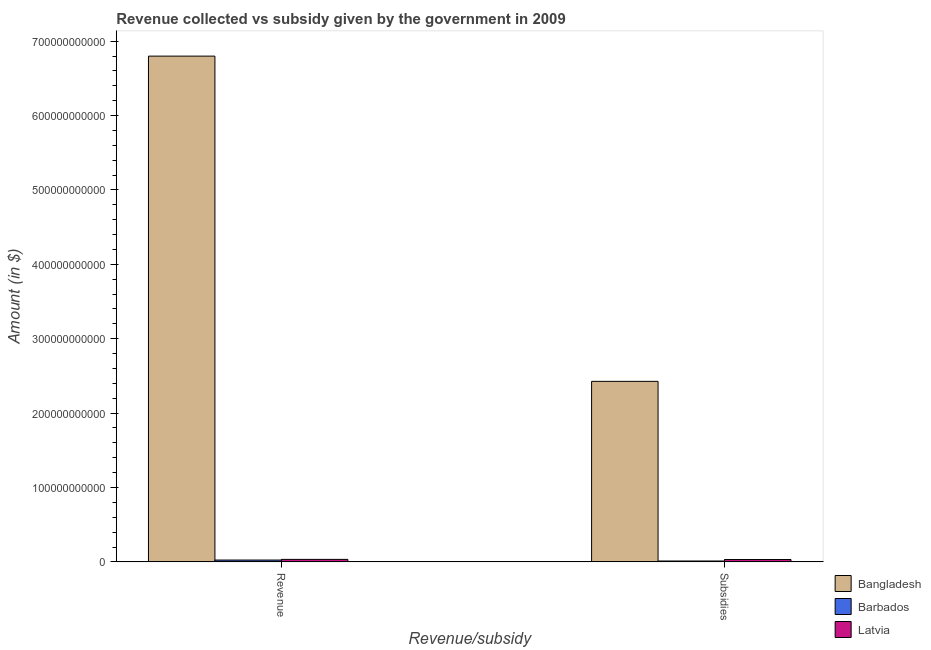How many different coloured bars are there?
Keep it short and to the point. 3. How many bars are there on the 2nd tick from the left?
Keep it short and to the point. 3. What is the label of the 2nd group of bars from the left?
Offer a terse response. Subsidies. What is the amount of revenue collected in Latvia?
Make the answer very short. 3.39e+09. Across all countries, what is the maximum amount of subsidies given?
Your answer should be very brief. 2.43e+11. Across all countries, what is the minimum amount of revenue collected?
Offer a very short reply. 2.50e+09. In which country was the amount of subsidies given minimum?
Your answer should be very brief. Barbados. What is the total amount of revenue collected in the graph?
Provide a short and direct response. 6.86e+11. What is the difference between the amount of revenue collected in Barbados and that in Bangladesh?
Provide a short and direct response. -6.77e+11. What is the difference between the amount of revenue collected in Latvia and the amount of subsidies given in Barbados?
Make the answer very short. 2.16e+09. What is the average amount of revenue collected per country?
Make the answer very short. 2.29e+11. What is the difference between the amount of revenue collected and amount of subsidies given in Bangladesh?
Provide a succinct answer. 4.37e+11. In how many countries, is the amount of revenue collected greater than 640000000000 $?
Your response must be concise. 1. What is the ratio of the amount of revenue collected in Latvia to that in Bangladesh?
Ensure brevity in your answer.  0. What does the 3rd bar from the left in Subsidies represents?
Give a very brief answer. Latvia. What does the 3rd bar from the right in Subsidies represents?
Keep it short and to the point. Bangladesh. How many bars are there?
Offer a very short reply. 6. How many countries are there in the graph?
Provide a succinct answer. 3. What is the difference between two consecutive major ticks on the Y-axis?
Give a very brief answer. 1.00e+11. Does the graph contain any zero values?
Provide a succinct answer. No. Does the graph contain grids?
Give a very brief answer. No. Where does the legend appear in the graph?
Offer a terse response. Bottom right. How many legend labels are there?
Provide a short and direct response. 3. How are the legend labels stacked?
Offer a very short reply. Vertical. What is the title of the graph?
Provide a succinct answer. Revenue collected vs subsidy given by the government in 2009. Does "High income" appear as one of the legend labels in the graph?
Your answer should be very brief. No. What is the label or title of the X-axis?
Offer a terse response. Revenue/subsidy. What is the label or title of the Y-axis?
Provide a short and direct response. Amount (in $). What is the Amount (in $) of Bangladesh in Revenue?
Make the answer very short. 6.80e+11. What is the Amount (in $) in Barbados in Revenue?
Ensure brevity in your answer.  2.50e+09. What is the Amount (in $) of Latvia in Revenue?
Keep it short and to the point. 3.39e+09. What is the Amount (in $) in Bangladesh in Subsidies?
Your response must be concise. 2.43e+11. What is the Amount (in $) of Barbados in Subsidies?
Your answer should be very brief. 1.23e+09. What is the Amount (in $) of Latvia in Subsidies?
Offer a terse response. 3.21e+09. Across all Revenue/subsidy, what is the maximum Amount (in $) of Bangladesh?
Offer a very short reply. 6.80e+11. Across all Revenue/subsidy, what is the maximum Amount (in $) of Barbados?
Provide a succinct answer. 2.50e+09. Across all Revenue/subsidy, what is the maximum Amount (in $) in Latvia?
Give a very brief answer. 3.39e+09. Across all Revenue/subsidy, what is the minimum Amount (in $) in Bangladesh?
Keep it short and to the point. 2.43e+11. Across all Revenue/subsidy, what is the minimum Amount (in $) of Barbados?
Your answer should be very brief. 1.23e+09. Across all Revenue/subsidy, what is the minimum Amount (in $) in Latvia?
Provide a succinct answer. 3.21e+09. What is the total Amount (in $) of Bangladesh in the graph?
Keep it short and to the point. 9.23e+11. What is the total Amount (in $) of Barbados in the graph?
Offer a very short reply. 3.72e+09. What is the total Amount (in $) of Latvia in the graph?
Give a very brief answer. 6.60e+09. What is the difference between the Amount (in $) of Bangladesh in Revenue and that in Subsidies?
Your answer should be very brief. 4.37e+11. What is the difference between the Amount (in $) in Barbados in Revenue and that in Subsidies?
Your answer should be compact. 1.27e+09. What is the difference between the Amount (in $) in Latvia in Revenue and that in Subsidies?
Provide a succinct answer. 1.82e+08. What is the difference between the Amount (in $) in Bangladesh in Revenue and the Amount (in $) in Barbados in Subsidies?
Provide a short and direct response. 6.79e+11. What is the difference between the Amount (in $) in Bangladesh in Revenue and the Amount (in $) in Latvia in Subsidies?
Your answer should be compact. 6.77e+11. What is the difference between the Amount (in $) in Barbados in Revenue and the Amount (in $) in Latvia in Subsidies?
Provide a short and direct response. -7.11e+08. What is the average Amount (in $) in Bangladesh per Revenue/subsidy?
Provide a short and direct response. 4.61e+11. What is the average Amount (in $) in Barbados per Revenue/subsidy?
Offer a terse response. 1.86e+09. What is the average Amount (in $) in Latvia per Revenue/subsidy?
Your answer should be very brief. 3.30e+09. What is the difference between the Amount (in $) in Bangladesh and Amount (in $) in Barbados in Revenue?
Provide a succinct answer. 6.77e+11. What is the difference between the Amount (in $) in Bangladesh and Amount (in $) in Latvia in Revenue?
Offer a terse response. 6.77e+11. What is the difference between the Amount (in $) in Barbados and Amount (in $) in Latvia in Revenue?
Provide a succinct answer. -8.93e+08. What is the difference between the Amount (in $) of Bangladesh and Amount (in $) of Barbados in Subsidies?
Ensure brevity in your answer.  2.41e+11. What is the difference between the Amount (in $) of Bangladesh and Amount (in $) of Latvia in Subsidies?
Provide a short and direct response. 2.40e+11. What is the difference between the Amount (in $) in Barbados and Amount (in $) in Latvia in Subsidies?
Provide a short and direct response. -1.98e+09. What is the ratio of the Amount (in $) of Bangladesh in Revenue to that in Subsidies?
Give a very brief answer. 2.8. What is the ratio of the Amount (in $) of Barbados in Revenue to that in Subsidies?
Make the answer very short. 2.03. What is the ratio of the Amount (in $) in Latvia in Revenue to that in Subsidies?
Your response must be concise. 1.06. What is the difference between the highest and the second highest Amount (in $) of Bangladesh?
Keep it short and to the point. 4.37e+11. What is the difference between the highest and the second highest Amount (in $) of Barbados?
Offer a very short reply. 1.27e+09. What is the difference between the highest and the second highest Amount (in $) of Latvia?
Provide a succinct answer. 1.82e+08. What is the difference between the highest and the lowest Amount (in $) of Bangladesh?
Make the answer very short. 4.37e+11. What is the difference between the highest and the lowest Amount (in $) in Barbados?
Your answer should be very brief. 1.27e+09. What is the difference between the highest and the lowest Amount (in $) of Latvia?
Your answer should be very brief. 1.82e+08. 